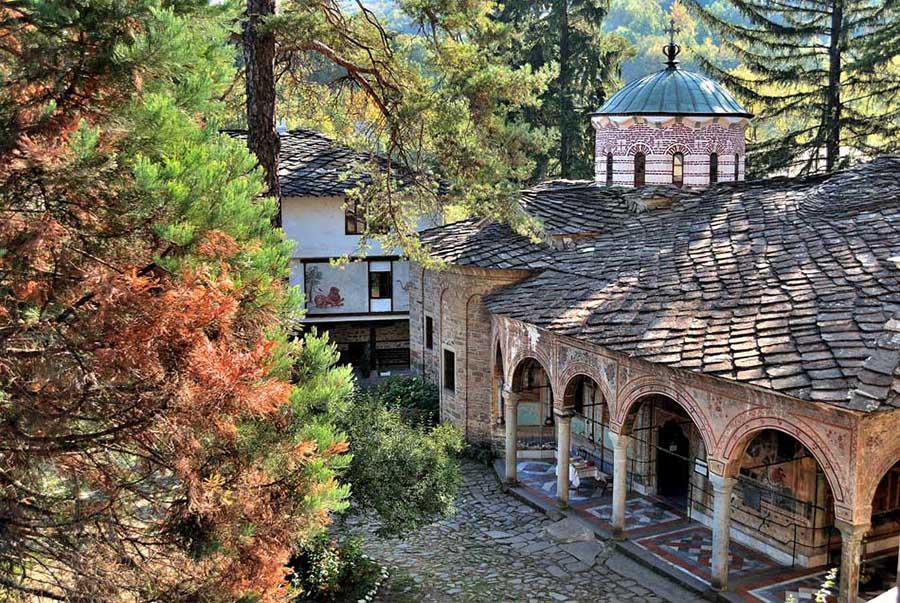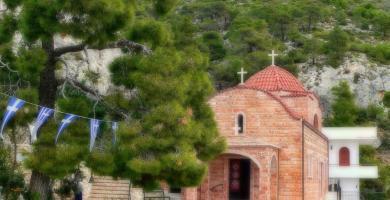The first image is the image on the left, the second image is the image on the right. Assess this claim about the two images: "Each image shows the outside of a building, no statues or indoors.". Correct or not? Answer yes or no. Yes. The first image is the image on the left, the second image is the image on the right. Considering the images on both sides, is "An image shows a string of colored flags suspended near a building with hills and trees behind it." valid? Answer yes or no. Yes. 